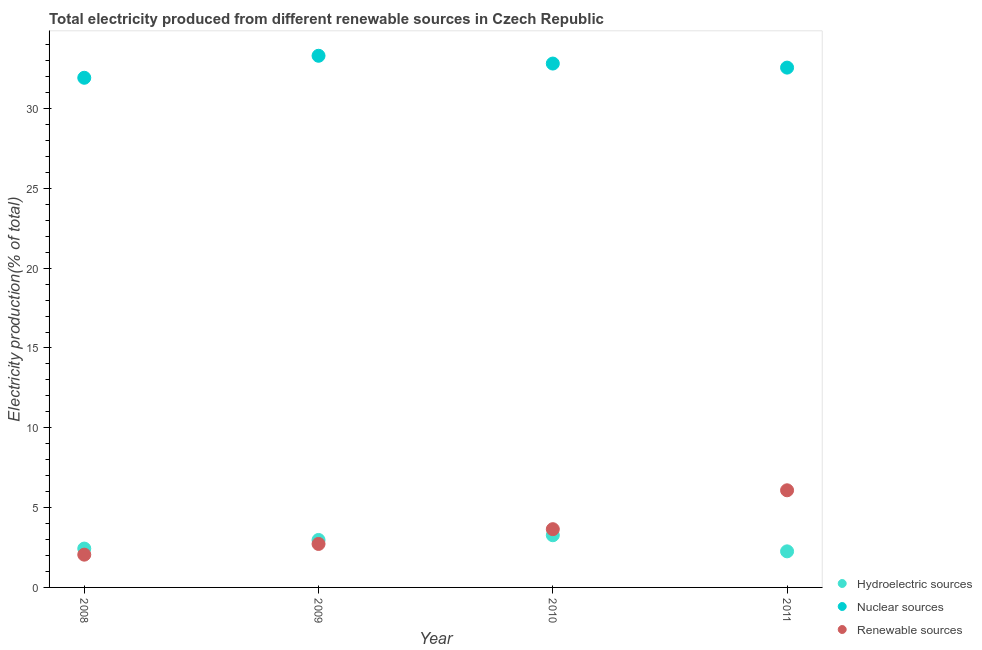How many different coloured dotlines are there?
Offer a very short reply. 3. Is the number of dotlines equal to the number of legend labels?
Make the answer very short. Yes. What is the percentage of electricity produced by nuclear sources in 2010?
Offer a very short reply. 32.82. Across all years, what is the maximum percentage of electricity produced by renewable sources?
Provide a short and direct response. 6.08. Across all years, what is the minimum percentage of electricity produced by renewable sources?
Offer a terse response. 2.05. In which year was the percentage of electricity produced by nuclear sources minimum?
Provide a succinct answer. 2008. What is the total percentage of electricity produced by hydroelectric sources in the graph?
Provide a short and direct response. 10.94. What is the difference between the percentage of electricity produced by renewable sources in 2009 and that in 2011?
Keep it short and to the point. -3.36. What is the difference between the percentage of electricity produced by hydroelectric sources in 2011 and the percentage of electricity produced by renewable sources in 2010?
Your response must be concise. -1.39. What is the average percentage of electricity produced by nuclear sources per year?
Give a very brief answer. 32.65. In the year 2010, what is the difference between the percentage of electricity produced by hydroelectric sources and percentage of electricity produced by renewable sources?
Your answer should be very brief. -0.38. In how many years, is the percentage of electricity produced by hydroelectric sources greater than 6 %?
Provide a succinct answer. 0. What is the ratio of the percentage of electricity produced by hydroelectric sources in 2009 to that in 2010?
Make the answer very short. 0.91. Is the difference between the percentage of electricity produced by renewable sources in 2009 and 2010 greater than the difference between the percentage of electricity produced by hydroelectric sources in 2009 and 2010?
Your response must be concise. No. What is the difference between the highest and the second highest percentage of electricity produced by renewable sources?
Provide a short and direct response. 2.44. What is the difference between the highest and the lowest percentage of electricity produced by renewable sources?
Offer a very short reply. 4.03. In how many years, is the percentage of electricity produced by hydroelectric sources greater than the average percentage of electricity produced by hydroelectric sources taken over all years?
Offer a terse response. 2. Is it the case that in every year, the sum of the percentage of electricity produced by hydroelectric sources and percentage of electricity produced by nuclear sources is greater than the percentage of electricity produced by renewable sources?
Your answer should be very brief. Yes. Does the percentage of electricity produced by nuclear sources monotonically increase over the years?
Provide a short and direct response. No. Is the percentage of electricity produced by nuclear sources strictly greater than the percentage of electricity produced by renewable sources over the years?
Provide a succinct answer. Yes. How many years are there in the graph?
Provide a succinct answer. 4. What is the difference between two consecutive major ticks on the Y-axis?
Provide a succinct answer. 5. Are the values on the major ticks of Y-axis written in scientific E-notation?
Your answer should be compact. No. Does the graph contain grids?
Your answer should be compact. No. Where does the legend appear in the graph?
Give a very brief answer. Bottom right. How are the legend labels stacked?
Provide a succinct answer. Vertical. What is the title of the graph?
Keep it short and to the point. Total electricity produced from different renewable sources in Czech Republic. Does "Ages 65 and above" appear as one of the legend labels in the graph?
Offer a very short reply. No. What is the label or title of the X-axis?
Your answer should be compact. Year. What is the Electricity production(% of total) of Hydroelectric sources in 2008?
Ensure brevity in your answer.  2.43. What is the Electricity production(% of total) in Nuclear sources in 2008?
Your response must be concise. 31.93. What is the Electricity production(% of total) in Renewable sources in 2008?
Keep it short and to the point. 2.05. What is the Electricity production(% of total) in Hydroelectric sources in 2009?
Keep it short and to the point. 2.97. What is the Electricity production(% of total) in Nuclear sources in 2009?
Give a very brief answer. 33.3. What is the Electricity production(% of total) of Renewable sources in 2009?
Offer a terse response. 2.72. What is the Electricity production(% of total) of Hydroelectric sources in 2010?
Your answer should be compact. 3.27. What is the Electricity production(% of total) in Nuclear sources in 2010?
Ensure brevity in your answer.  32.82. What is the Electricity production(% of total) of Renewable sources in 2010?
Offer a terse response. 3.65. What is the Electricity production(% of total) of Hydroelectric sources in 2011?
Offer a terse response. 2.26. What is the Electricity production(% of total) in Nuclear sources in 2011?
Your answer should be very brief. 32.56. What is the Electricity production(% of total) of Renewable sources in 2011?
Offer a terse response. 6.08. Across all years, what is the maximum Electricity production(% of total) in Hydroelectric sources?
Your answer should be compact. 3.27. Across all years, what is the maximum Electricity production(% of total) of Nuclear sources?
Offer a terse response. 33.3. Across all years, what is the maximum Electricity production(% of total) in Renewable sources?
Provide a short and direct response. 6.08. Across all years, what is the minimum Electricity production(% of total) of Hydroelectric sources?
Make the answer very short. 2.26. Across all years, what is the minimum Electricity production(% of total) in Nuclear sources?
Your answer should be very brief. 31.93. Across all years, what is the minimum Electricity production(% of total) of Renewable sources?
Keep it short and to the point. 2.05. What is the total Electricity production(% of total) in Hydroelectric sources in the graph?
Your response must be concise. 10.94. What is the total Electricity production(% of total) in Nuclear sources in the graph?
Offer a very short reply. 130.61. What is the total Electricity production(% of total) in Renewable sources in the graph?
Keep it short and to the point. 14.51. What is the difference between the Electricity production(% of total) in Hydroelectric sources in 2008 and that in 2009?
Offer a terse response. -0.54. What is the difference between the Electricity production(% of total) in Nuclear sources in 2008 and that in 2009?
Ensure brevity in your answer.  -1.38. What is the difference between the Electricity production(% of total) in Renewable sources in 2008 and that in 2009?
Offer a terse response. -0.67. What is the difference between the Electricity production(% of total) in Hydroelectric sources in 2008 and that in 2010?
Your answer should be very brief. -0.84. What is the difference between the Electricity production(% of total) in Nuclear sources in 2008 and that in 2010?
Provide a succinct answer. -0.89. What is the difference between the Electricity production(% of total) in Renewable sources in 2008 and that in 2010?
Offer a terse response. -1.6. What is the difference between the Electricity production(% of total) in Hydroelectric sources in 2008 and that in 2011?
Your response must be concise. 0.17. What is the difference between the Electricity production(% of total) in Nuclear sources in 2008 and that in 2011?
Offer a very short reply. -0.64. What is the difference between the Electricity production(% of total) in Renewable sources in 2008 and that in 2011?
Your answer should be compact. -4.03. What is the difference between the Electricity production(% of total) in Hydroelectric sources in 2009 and that in 2010?
Keep it short and to the point. -0.3. What is the difference between the Electricity production(% of total) in Nuclear sources in 2009 and that in 2010?
Keep it short and to the point. 0.49. What is the difference between the Electricity production(% of total) of Renewable sources in 2009 and that in 2010?
Your answer should be very brief. -0.93. What is the difference between the Electricity production(% of total) in Hydroelectric sources in 2009 and that in 2011?
Your answer should be very brief. 0.71. What is the difference between the Electricity production(% of total) of Nuclear sources in 2009 and that in 2011?
Provide a short and direct response. 0.74. What is the difference between the Electricity production(% of total) of Renewable sources in 2009 and that in 2011?
Make the answer very short. -3.36. What is the difference between the Electricity production(% of total) in Hydroelectric sources in 2010 and that in 2011?
Your response must be concise. 1.01. What is the difference between the Electricity production(% of total) of Nuclear sources in 2010 and that in 2011?
Give a very brief answer. 0.25. What is the difference between the Electricity production(% of total) of Renewable sources in 2010 and that in 2011?
Offer a terse response. -2.44. What is the difference between the Electricity production(% of total) of Hydroelectric sources in 2008 and the Electricity production(% of total) of Nuclear sources in 2009?
Provide a succinct answer. -30.87. What is the difference between the Electricity production(% of total) in Hydroelectric sources in 2008 and the Electricity production(% of total) in Renewable sources in 2009?
Provide a short and direct response. -0.29. What is the difference between the Electricity production(% of total) of Nuclear sources in 2008 and the Electricity production(% of total) of Renewable sources in 2009?
Ensure brevity in your answer.  29.2. What is the difference between the Electricity production(% of total) of Hydroelectric sources in 2008 and the Electricity production(% of total) of Nuclear sources in 2010?
Offer a very short reply. -30.38. What is the difference between the Electricity production(% of total) in Hydroelectric sources in 2008 and the Electricity production(% of total) in Renewable sources in 2010?
Offer a terse response. -1.22. What is the difference between the Electricity production(% of total) of Nuclear sources in 2008 and the Electricity production(% of total) of Renewable sources in 2010?
Ensure brevity in your answer.  28.28. What is the difference between the Electricity production(% of total) in Hydroelectric sources in 2008 and the Electricity production(% of total) in Nuclear sources in 2011?
Provide a succinct answer. -30.13. What is the difference between the Electricity production(% of total) of Hydroelectric sources in 2008 and the Electricity production(% of total) of Renewable sources in 2011?
Your answer should be compact. -3.65. What is the difference between the Electricity production(% of total) in Nuclear sources in 2008 and the Electricity production(% of total) in Renewable sources in 2011?
Offer a very short reply. 25.84. What is the difference between the Electricity production(% of total) of Hydroelectric sources in 2009 and the Electricity production(% of total) of Nuclear sources in 2010?
Your answer should be compact. -29.84. What is the difference between the Electricity production(% of total) in Hydroelectric sources in 2009 and the Electricity production(% of total) in Renewable sources in 2010?
Your answer should be compact. -0.68. What is the difference between the Electricity production(% of total) in Nuclear sources in 2009 and the Electricity production(% of total) in Renewable sources in 2010?
Provide a short and direct response. 29.65. What is the difference between the Electricity production(% of total) of Hydroelectric sources in 2009 and the Electricity production(% of total) of Nuclear sources in 2011?
Ensure brevity in your answer.  -29.59. What is the difference between the Electricity production(% of total) in Hydroelectric sources in 2009 and the Electricity production(% of total) in Renewable sources in 2011?
Your answer should be very brief. -3.11. What is the difference between the Electricity production(% of total) of Nuclear sources in 2009 and the Electricity production(% of total) of Renewable sources in 2011?
Your answer should be compact. 27.22. What is the difference between the Electricity production(% of total) in Hydroelectric sources in 2010 and the Electricity production(% of total) in Nuclear sources in 2011?
Provide a short and direct response. -29.29. What is the difference between the Electricity production(% of total) in Hydroelectric sources in 2010 and the Electricity production(% of total) in Renewable sources in 2011?
Make the answer very short. -2.82. What is the difference between the Electricity production(% of total) of Nuclear sources in 2010 and the Electricity production(% of total) of Renewable sources in 2011?
Provide a succinct answer. 26.73. What is the average Electricity production(% of total) of Hydroelectric sources per year?
Your response must be concise. 2.73. What is the average Electricity production(% of total) of Nuclear sources per year?
Make the answer very short. 32.65. What is the average Electricity production(% of total) of Renewable sources per year?
Offer a very short reply. 3.63. In the year 2008, what is the difference between the Electricity production(% of total) in Hydroelectric sources and Electricity production(% of total) in Nuclear sources?
Provide a succinct answer. -29.49. In the year 2008, what is the difference between the Electricity production(% of total) of Hydroelectric sources and Electricity production(% of total) of Renewable sources?
Your response must be concise. 0.38. In the year 2008, what is the difference between the Electricity production(% of total) of Nuclear sources and Electricity production(% of total) of Renewable sources?
Make the answer very short. 29.87. In the year 2009, what is the difference between the Electricity production(% of total) of Hydroelectric sources and Electricity production(% of total) of Nuclear sources?
Make the answer very short. -30.33. In the year 2009, what is the difference between the Electricity production(% of total) of Hydroelectric sources and Electricity production(% of total) of Renewable sources?
Your answer should be very brief. 0.25. In the year 2009, what is the difference between the Electricity production(% of total) of Nuclear sources and Electricity production(% of total) of Renewable sources?
Your response must be concise. 30.58. In the year 2010, what is the difference between the Electricity production(% of total) of Hydroelectric sources and Electricity production(% of total) of Nuclear sources?
Your answer should be compact. -29.55. In the year 2010, what is the difference between the Electricity production(% of total) of Hydroelectric sources and Electricity production(% of total) of Renewable sources?
Offer a terse response. -0.38. In the year 2010, what is the difference between the Electricity production(% of total) in Nuclear sources and Electricity production(% of total) in Renewable sources?
Provide a succinct answer. 29.17. In the year 2011, what is the difference between the Electricity production(% of total) of Hydroelectric sources and Electricity production(% of total) of Nuclear sources?
Provide a short and direct response. -30.3. In the year 2011, what is the difference between the Electricity production(% of total) of Hydroelectric sources and Electricity production(% of total) of Renewable sources?
Your response must be concise. -3.82. In the year 2011, what is the difference between the Electricity production(% of total) in Nuclear sources and Electricity production(% of total) in Renewable sources?
Provide a short and direct response. 26.48. What is the ratio of the Electricity production(% of total) of Hydroelectric sources in 2008 to that in 2009?
Keep it short and to the point. 0.82. What is the ratio of the Electricity production(% of total) of Nuclear sources in 2008 to that in 2009?
Provide a short and direct response. 0.96. What is the ratio of the Electricity production(% of total) in Renewable sources in 2008 to that in 2009?
Offer a very short reply. 0.75. What is the ratio of the Electricity production(% of total) in Hydroelectric sources in 2008 to that in 2010?
Your response must be concise. 0.74. What is the ratio of the Electricity production(% of total) of Nuclear sources in 2008 to that in 2010?
Your response must be concise. 0.97. What is the ratio of the Electricity production(% of total) of Renewable sources in 2008 to that in 2010?
Make the answer very short. 0.56. What is the ratio of the Electricity production(% of total) of Nuclear sources in 2008 to that in 2011?
Provide a succinct answer. 0.98. What is the ratio of the Electricity production(% of total) in Renewable sources in 2008 to that in 2011?
Make the answer very short. 0.34. What is the ratio of the Electricity production(% of total) of Hydroelectric sources in 2009 to that in 2010?
Provide a succinct answer. 0.91. What is the ratio of the Electricity production(% of total) of Nuclear sources in 2009 to that in 2010?
Your answer should be compact. 1.01. What is the ratio of the Electricity production(% of total) of Renewable sources in 2009 to that in 2010?
Make the answer very short. 0.75. What is the ratio of the Electricity production(% of total) of Hydroelectric sources in 2009 to that in 2011?
Make the answer very short. 1.32. What is the ratio of the Electricity production(% of total) of Nuclear sources in 2009 to that in 2011?
Keep it short and to the point. 1.02. What is the ratio of the Electricity production(% of total) in Renewable sources in 2009 to that in 2011?
Offer a terse response. 0.45. What is the ratio of the Electricity production(% of total) of Hydroelectric sources in 2010 to that in 2011?
Your answer should be compact. 1.45. What is the ratio of the Electricity production(% of total) in Nuclear sources in 2010 to that in 2011?
Offer a terse response. 1.01. What is the ratio of the Electricity production(% of total) in Renewable sources in 2010 to that in 2011?
Give a very brief answer. 0.6. What is the difference between the highest and the second highest Electricity production(% of total) of Hydroelectric sources?
Your answer should be very brief. 0.3. What is the difference between the highest and the second highest Electricity production(% of total) of Nuclear sources?
Provide a succinct answer. 0.49. What is the difference between the highest and the second highest Electricity production(% of total) of Renewable sources?
Your answer should be very brief. 2.44. What is the difference between the highest and the lowest Electricity production(% of total) of Hydroelectric sources?
Ensure brevity in your answer.  1.01. What is the difference between the highest and the lowest Electricity production(% of total) in Nuclear sources?
Offer a very short reply. 1.38. What is the difference between the highest and the lowest Electricity production(% of total) in Renewable sources?
Offer a terse response. 4.03. 